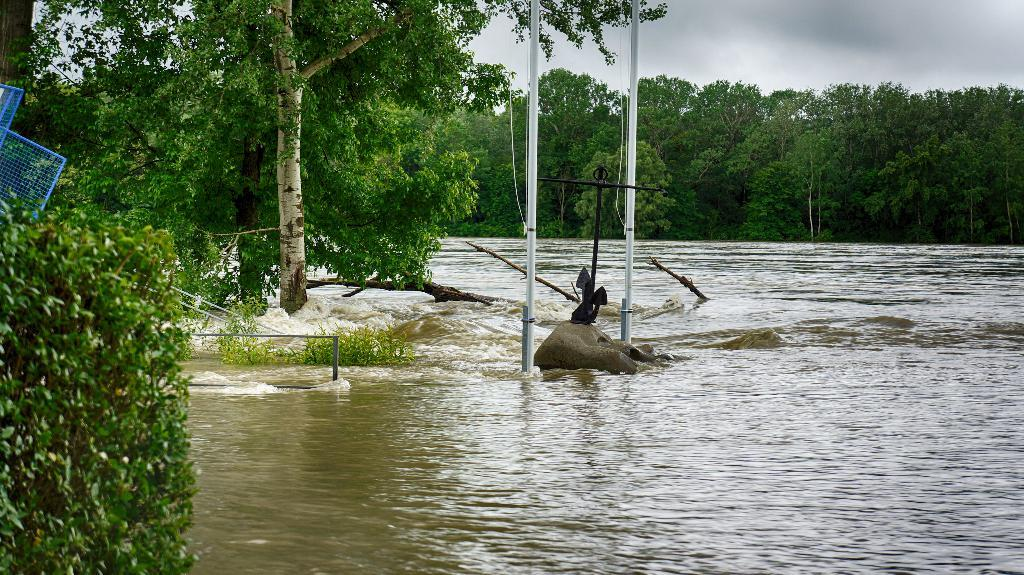What type of vegetation can be seen in the image? There are trees in the image. What structures are present in the image? There are poles and a fence in the image. What material is used for the mesh in the image? The mesh in the image is not specified, but it could be made of various materials like metal or plastic. What is visible at the top of the image? The sky is visible at the top of the image. What objects are at the bottom of the image? There are logs at the bottom of the image. What natural element is on the water in the image? There is a rock on the water in the image. What type of cushion can be seen on the rock in the image? There is no cushion present on the rock in the image. What type of iron is visible in the image? There is no iron visible in the image. 